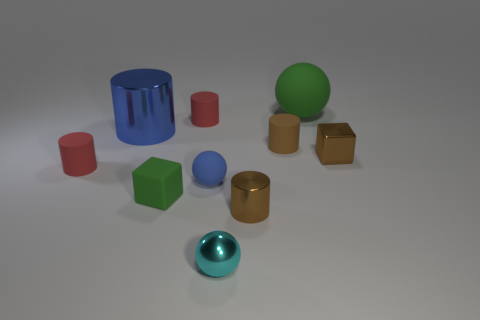How many objects in the image have reflective surfaces? There are two objects with reflective surfaces: the metallic teal sphere and the golden cylinder. 